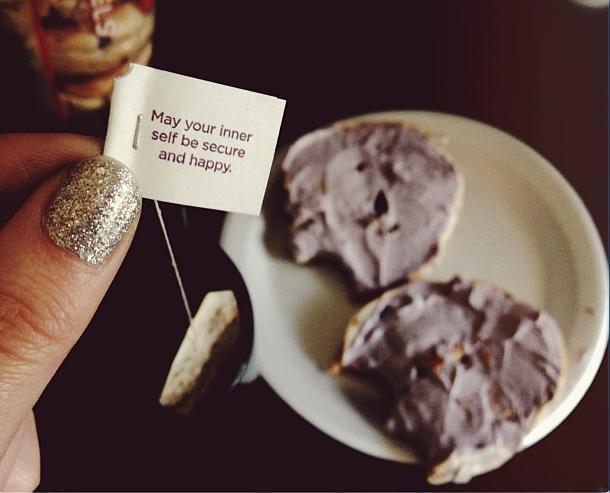How many donuts are there?
Give a very brief answer. 2. How many surfboards are there?
Give a very brief answer. 0. 